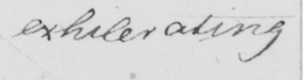Can you read and transcribe this handwriting? exhilerating 